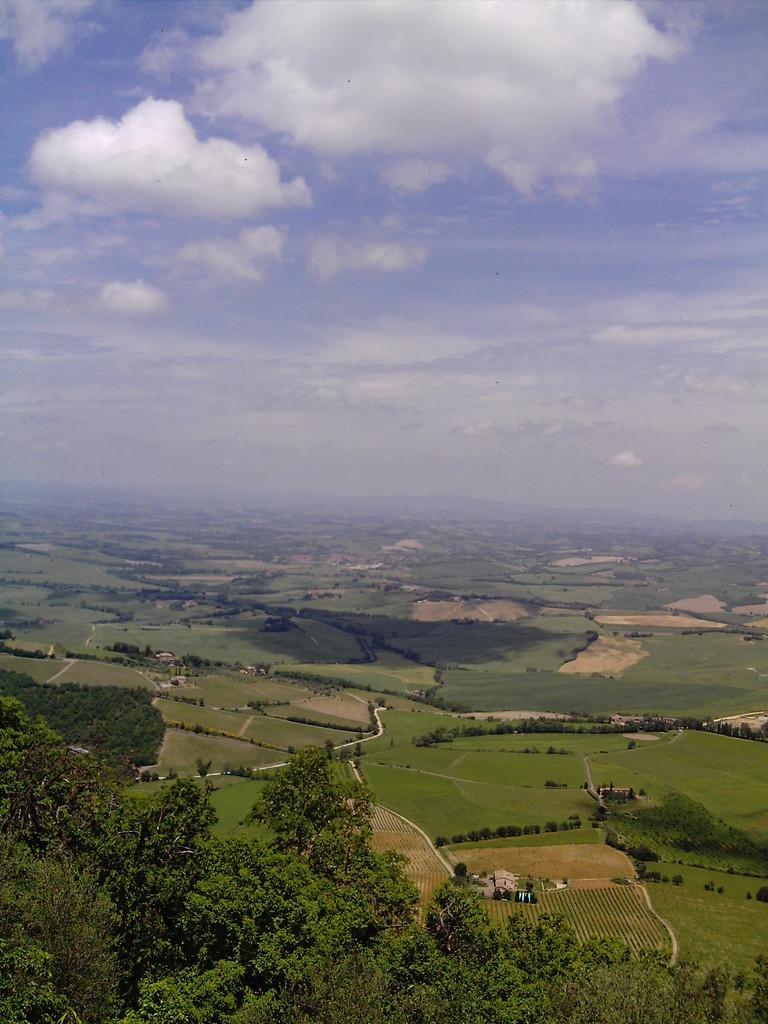Can you describe this image briefly? In this image we can see ground and trees. In the background there is sky with clouds. 